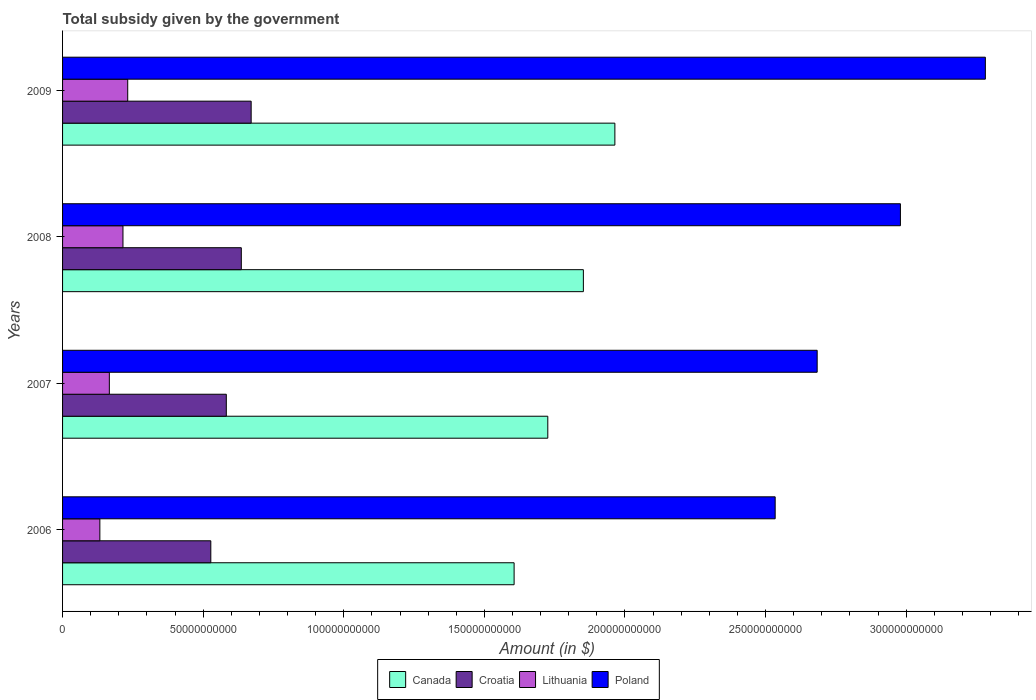How many different coloured bars are there?
Provide a short and direct response. 4. Are the number of bars per tick equal to the number of legend labels?
Provide a succinct answer. Yes. Are the number of bars on each tick of the Y-axis equal?
Offer a very short reply. Yes. How many bars are there on the 1st tick from the bottom?
Ensure brevity in your answer.  4. What is the total revenue collected by the government in Croatia in 2006?
Make the answer very short. 5.27e+1. Across all years, what is the maximum total revenue collected by the government in Lithuania?
Ensure brevity in your answer.  2.32e+1. Across all years, what is the minimum total revenue collected by the government in Poland?
Keep it short and to the point. 2.53e+11. What is the total total revenue collected by the government in Canada in the graph?
Your answer should be compact. 7.15e+11. What is the difference between the total revenue collected by the government in Poland in 2006 and that in 2007?
Make the answer very short. -1.49e+1. What is the difference between the total revenue collected by the government in Lithuania in 2006 and the total revenue collected by the government in Canada in 2008?
Offer a very short reply. -1.72e+11. What is the average total revenue collected by the government in Canada per year?
Ensure brevity in your answer.  1.79e+11. In the year 2008, what is the difference between the total revenue collected by the government in Canada and total revenue collected by the government in Croatia?
Make the answer very short. 1.22e+11. What is the ratio of the total revenue collected by the government in Lithuania in 2007 to that in 2009?
Your response must be concise. 0.72. Is the difference between the total revenue collected by the government in Canada in 2007 and 2008 greater than the difference between the total revenue collected by the government in Croatia in 2007 and 2008?
Your answer should be very brief. No. What is the difference between the highest and the second highest total revenue collected by the government in Croatia?
Offer a terse response. 3.51e+09. What is the difference between the highest and the lowest total revenue collected by the government in Croatia?
Give a very brief answer. 1.43e+1. Is the sum of the total revenue collected by the government in Lithuania in 2006 and 2007 greater than the maximum total revenue collected by the government in Croatia across all years?
Your answer should be compact. No. Is it the case that in every year, the sum of the total revenue collected by the government in Canada and total revenue collected by the government in Lithuania is greater than the sum of total revenue collected by the government in Croatia and total revenue collected by the government in Poland?
Ensure brevity in your answer.  Yes. What does the 3rd bar from the bottom in 2006 represents?
Make the answer very short. Lithuania. Is it the case that in every year, the sum of the total revenue collected by the government in Canada and total revenue collected by the government in Poland is greater than the total revenue collected by the government in Croatia?
Provide a short and direct response. Yes. Are all the bars in the graph horizontal?
Ensure brevity in your answer.  Yes. Are the values on the major ticks of X-axis written in scientific E-notation?
Your answer should be very brief. No. Where does the legend appear in the graph?
Your answer should be very brief. Bottom center. What is the title of the graph?
Your answer should be compact. Total subsidy given by the government. What is the label or title of the X-axis?
Give a very brief answer. Amount (in $). What is the label or title of the Y-axis?
Provide a short and direct response. Years. What is the Amount (in $) of Canada in 2006?
Make the answer very short. 1.61e+11. What is the Amount (in $) of Croatia in 2006?
Offer a very short reply. 5.27e+1. What is the Amount (in $) in Lithuania in 2006?
Provide a succinct answer. 1.33e+1. What is the Amount (in $) in Poland in 2006?
Offer a terse response. 2.53e+11. What is the Amount (in $) of Canada in 2007?
Ensure brevity in your answer.  1.73e+11. What is the Amount (in $) in Croatia in 2007?
Provide a short and direct response. 5.82e+1. What is the Amount (in $) of Lithuania in 2007?
Keep it short and to the point. 1.66e+1. What is the Amount (in $) of Poland in 2007?
Keep it short and to the point. 2.68e+11. What is the Amount (in $) in Canada in 2008?
Offer a terse response. 1.85e+11. What is the Amount (in $) of Croatia in 2008?
Make the answer very short. 6.36e+1. What is the Amount (in $) in Lithuania in 2008?
Keep it short and to the point. 2.15e+1. What is the Amount (in $) in Poland in 2008?
Provide a succinct answer. 2.98e+11. What is the Amount (in $) in Canada in 2009?
Give a very brief answer. 1.96e+11. What is the Amount (in $) in Croatia in 2009?
Your answer should be very brief. 6.71e+1. What is the Amount (in $) in Lithuania in 2009?
Provide a short and direct response. 2.32e+1. What is the Amount (in $) in Poland in 2009?
Make the answer very short. 3.28e+11. Across all years, what is the maximum Amount (in $) of Canada?
Your answer should be compact. 1.96e+11. Across all years, what is the maximum Amount (in $) of Croatia?
Your response must be concise. 6.71e+1. Across all years, what is the maximum Amount (in $) of Lithuania?
Provide a succinct answer. 2.32e+1. Across all years, what is the maximum Amount (in $) of Poland?
Ensure brevity in your answer.  3.28e+11. Across all years, what is the minimum Amount (in $) in Canada?
Provide a succinct answer. 1.61e+11. Across all years, what is the minimum Amount (in $) in Croatia?
Give a very brief answer. 5.27e+1. Across all years, what is the minimum Amount (in $) of Lithuania?
Your answer should be very brief. 1.33e+1. Across all years, what is the minimum Amount (in $) in Poland?
Your answer should be very brief. 2.53e+11. What is the total Amount (in $) of Canada in the graph?
Your answer should be very brief. 7.15e+11. What is the total Amount (in $) of Croatia in the graph?
Provide a short and direct response. 2.42e+11. What is the total Amount (in $) in Lithuania in the graph?
Your answer should be compact. 7.45e+1. What is the total Amount (in $) in Poland in the graph?
Keep it short and to the point. 1.15e+12. What is the difference between the Amount (in $) in Canada in 2006 and that in 2007?
Provide a succinct answer. -1.20e+1. What is the difference between the Amount (in $) of Croatia in 2006 and that in 2007?
Make the answer very short. -5.51e+09. What is the difference between the Amount (in $) of Lithuania in 2006 and that in 2007?
Ensure brevity in your answer.  -3.37e+09. What is the difference between the Amount (in $) of Poland in 2006 and that in 2007?
Give a very brief answer. -1.49e+1. What is the difference between the Amount (in $) of Canada in 2006 and that in 2008?
Keep it short and to the point. -2.46e+1. What is the difference between the Amount (in $) in Croatia in 2006 and that in 2008?
Make the answer very short. -1.08e+1. What is the difference between the Amount (in $) of Lithuania in 2006 and that in 2008?
Ensure brevity in your answer.  -8.22e+09. What is the difference between the Amount (in $) of Poland in 2006 and that in 2008?
Give a very brief answer. -4.45e+1. What is the difference between the Amount (in $) of Canada in 2006 and that in 2009?
Your response must be concise. -3.58e+1. What is the difference between the Amount (in $) in Croatia in 2006 and that in 2009?
Make the answer very short. -1.43e+1. What is the difference between the Amount (in $) of Lithuania in 2006 and that in 2009?
Make the answer very short. -9.90e+09. What is the difference between the Amount (in $) in Poland in 2006 and that in 2009?
Ensure brevity in your answer.  -7.47e+1. What is the difference between the Amount (in $) of Canada in 2007 and that in 2008?
Make the answer very short. -1.27e+1. What is the difference between the Amount (in $) of Croatia in 2007 and that in 2008?
Provide a succinct answer. -5.33e+09. What is the difference between the Amount (in $) of Lithuania in 2007 and that in 2008?
Make the answer very short. -4.85e+09. What is the difference between the Amount (in $) of Poland in 2007 and that in 2008?
Make the answer very short. -2.96e+1. What is the difference between the Amount (in $) of Canada in 2007 and that in 2009?
Your response must be concise. -2.39e+1. What is the difference between the Amount (in $) in Croatia in 2007 and that in 2009?
Ensure brevity in your answer.  -8.84e+09. What is the difference between the Amount (in $) of Lithuania in 2007 and that in 2009?
Your answer should be compact. -6.53e+09. What is the difference between the Amount (in $) in Poland in 2007 and that in 2009?
Your answer should be very brief. -5.98e+1. What is the difference between the Amount (in $) in Canada in 2008 and that in 2009?
Offer a terse response. -1.12e+1. What is the difference between the Amount (in $) in Croatia in 2008 and that in 2009?
Offer a very short reply. -3.51e+09. What is the difference between the Amount (in $) in Lithuania in 2008 and that in 2009?
Your answer should be very brief. -1.69e+09. What is the difference between the Amount (in $) of Poland in 2008 and that in 2009?
Keep it short and to the point. -3.02e+1. What is the difference between the Amount (in $) of Canada in 2006 and the Amount (in $) of Croatia in 2007?
Provide a succinct answer. 1.02e+11. What is the difference between the Amount (in $) in Canada in 2006 and the Amount (in $) in Lithuania in 2007?
Give a very brief answer. 1.44e+11. What is the difference between the Amount (in $) of Canada in 2006 and the Amount (in $) of Poland in 2007?
Offer a terse response. -1.08e+11. What is the difference between the Amount (in $) in Croatia in 2006 and the Amount (in $) in Lithuania in 2007?
Your answer should be very brief. 3.61e+1. What is the difference between the Amount (in $) of Croatia in 2006 and the Amount (in $) of Poland in 2007?
Your response must be concise. -2.16e+11. What is the difference between the Amount (in $) in Lithuania in 2006 and the Amount (in $) in Poland in 2007?
Your response must be concise. -2.55e+11. What is the difference between the Amount (in $) in Canada in 2006 and the Amount (in $) in Croatia in 2008?
Provide a short and direct response. 9.70e+1. What is the difference between the Amount (in $) of Canada in 2006 and the Amount (in $) of Lithuania in 2008?
Give a very brief answer. 1.39e+11. What is the difference between the Amount (in $) of Canada in 2006 and the Amount (in $) of Poland in 2008?
Offer a terse response. -1.37e+11. What is the difference between the Amount (in $) in Croatia in 2006 and the Amount (in $) in Lithuania in 2008?
Keep it short and to the point. 3.12e+1. What is the difference between the Amount (in $) of Croatia in 2006 and the Amount (in $) of Poland in 2008?
Your response must be concise. -2.45e+11. What is the difference between the Amount (in $) in Lithuania in 2006 and the Amount (in $) in Poland in 2008?
Offer a very short reply. -2.85e+11. What is the difference between the Amount (in $) of Canada in 2006 and the Amount (in $) of Croatia in 2009?
Make the answer very short. 9.35e+1. What is the difference between the Amount (in $) in Canada in 2006 and the Amount (in $) in Lithuania in 2009?
Your response must be concise. 1.37e+11. What is the difference between the Amount (in $) of Canada in 2006 and the Amount (in $) of Poland in 2009?
Keep it short and to the point. -1.68e+11. What is the difference between the Amount (in $) in Croatia in 2006 and the Amount (in $) in Lithuania in 2009?
Your answer should be very brief. 2.96e+1. What is the difference between the Amount (in $) in Croatia in 2006 and the Amount (in $) in Poland in 2009?
Make the answer very short. -2.75e+11. What is the difference between the Amount (in $) of Lithuania in 2006 and the Amount (in $) of Poland in 2009?
Provide a succinct answer. -3.15e+11. What is the difference between the Amount (in $) in Canada in 2007 and the Amount (in $) in Croatia in 2008?
Ensure brevity in your answer.  1.09e+11. What is the difference between the Amount (in $) of Canada in 2007 and the Amount (in $) of Lithuania in 2008?
Give a very brief answer. 1.51e+11. What is the difference between the Amount (in $) in Canada in 2007 and the Amount (in $) in Poland in 2008?
Offer a terse response. -1.25e+11. What is the difference between the Amount (in $) of Croatia in 2007 and the Amount (in $) of Lithuania in 2008?
Your answer should be compact. 3.67e+1. What is the difference between the Amount (in $) of Croatia in 2007 and the Amount (in $) of Poland in 2008?
Provide a succinct answer. -2.40e+11. What is the difference between the Amount (in $) in Lithuania in 2007 and the Amount (in $) in Poland in 2008?
Offer a terse response. -2.81e+11. What is the difference between the Amount (in $) of Canada in 2007 and the Amount (in $) of Croatia in 2009?
Offer a terse response. 1.05e+11. What is the difference between the Amount (in $) of Canada in 2007 and the Amount (in $) of Lithuania in 2009?
Your answer should be very brief. 1.49e+11. What is the difference between the Amount (in $) in Canada in 2007 and the Amount (in $) in Poland in 2009?
Provide a short and direct response. -1.56e+11. What is the difference between the Amount (in $) in Croatia in 2007 and the Amount (in $) in Lithuania in 2009?
Provide a short and direct response. 3.51e+1. What is the difference between the Amount (in $) of Croatia in 2007 and the Amount (in $) of Poland in 2009?
Your response must be concise. -2.70e+11. What is the difference between the Amount (in $) of Lithuania in 2007 and the Amount (in $) of Poland in 2009?
Offer a very short reply. -3.12e+11. What is the difference between the Amount (in $) of Canada in 2008 and the Amount (in $) of Croatia in 2009?
Provide a succinct answer. 1.18e+11. What is the difference between the Amount (in $) in Canada in 2008 and the Amount (in $) in Lithuania in 2009?
Your answer should be compact. 1.62e+11. What is the difference between the Amount (in $) in Canada in 2008 and the Amount (in $) in Poland in 2009?
Give a very brief answer. -1.43e+11. What is the difference between the Amount (in $) of Croatia in 2008 and the Amount (in $) of Lithuania in 2009?
Your response must be concise. 4.04e+1. What is the difference between the Amount (in $) in Croatia in 2008 and the Amount (in $) in Poland in 2009?
Ensure brevity in your answer.  -2.65e+11. What is the difference between the Amount (in $) of Lithuania in 2008 and the Amount (in $) of Poland in 2009?
Keep it short and to the point. -3.07e+11. What is the average Amount (in $) in Canada per year?
Your answer should be very brief. 1.79e+11. What is the average Amount (in $) in Croatia per year?
Make the answer very short. 6.04e+1. What is the average Amount (in $) in Lithuania per year?
Provide a succinct answer. 1.86e+1. What is the average Amount (in $) in Poland per year?
Offer a very short reply. 2.87e+11. In the year 2006, what is the difference between the Amount (in $) of Canada and Amount (in $) of Croatia?
Keep it short and to the point. 1.08e+11. In the year 2006, what is the difference between the Amount (in $) in Canada and Amount (in $) in Lithuania?
Provide a succinct answer. 1.47e+11. In the year 2006, what is the difference between the Amount (in $) in Canada and Amount (in $) in Poland?
Give a very brief answer. -9.28e+1. In the year 2006, what is the difference between the Amount (in $) of Croatia and Amount (in $) of Lithuania?
Your answer should be compact. 3.95e+1. In the year 2006, what is the difference between the Amount (in $) of Croatia and Amount (in $) of Poland?
Provide a succinct answer. -2.01e+11. In the year 2006, what is the difference between the Amount (in $) of Lithuania and Amount (in $) of Poland?
Your answer should be very brief. -2.40e+11. In the year 2007, what is the difference between the Amount (in $) of Canada and Amount (in $) of Croatia?
Make the answer very short. 1.14e+11. In the year 2007, what is the difference between the Amount (in $) in Canada and Amount (in $) in Lithuania?
Your response must be concise. 1.56e+11. In the year 2007, what is the difference between the Amount (in $) in Canada and Amount (in $) in Poland?
Offer a terse response. -9.58e+1. In the year 2007, what is the difference between the Amount (in $) of Croatia and Amount (in $) of Lithuania?
Give a very brief answer. 4.16e+1. In the year 2007, what is the difference between the Amount (in $) of Croatia and Amount (in $) of Poland?
Your response must be concise. -2.10e+11. In the year 2007, what is the difference between the Amount (in $) of Lithuania and Amount (in $) of Poland?
Your response must be concise. -2.52e+11. In the year 2008, what is the difference between the Amount (in $) in Canada and Amount (in $) in Croatia?
Keep it short and to the point. 1.22e+11. In the year 2008, what is the difference between the Amount (in $) of Canada and Amount (in $) of Lithuania?
Offer a terse response. 1.64e+11. In the year 2008, what is the difference between the Amount (in $) of Canada and Amount (in $) of Poland?
Offer a terse response. -1.13e+11. In the year 2008, what is the difference between the Amount (in $) in Croatia and Amount (in $) in Lithuania?
Offer a terse response. 4.21e+1. In the year 2008, what is the difference between the Amount (in $) in Croatia and Amount (in $) in Poland?
Your answer should be very brief. -2.34e+11. In the year 2008, what is the difference between the Amount (in $) of Lithuania and Amount (in $) of Poland?
Your answer should be compact. -2.76e+11. In the year 2009, what is the difference between the Amount (in $) in Canada and Amount (in $) in Croatia?
Offer a terse response. 1.29e+11. In the year 2009, what is the difference between the Amount (in $) of Canada and Amount (in $) of Lithuania?
Give a very brief answer. 1.73e+11. In the year 2009, what is the difference between the Amount (in $) in Canada and Amount (in $) in Poland?
Give a very brief answer. -1.32e+11. In the year 2009, what is the difference between the Amount (in $) in Croatia and Amount (in $) in Lithuania?
Offer a very short reply. 4.39e+1. In the year 2009, what is the difference between the Amount (in $) in Croatia and Amount (in $) in Poland?
Provide a succinct answer. -2.61e+11. In the year 2009, what is the difference between the Amount (in $) in Lithuania and Amount (in $) in Poland?
Make the answer very short. -3.05e+11. What is the ratio of the Amount (in $) in Canada in 2006 to that in 2007?
Your answer should be compact. 0.93. What is the ratio of the Amount (in $) in Croatia in 2006 to that in 2007?
Your response must be concise. 0.91. What is the ratio of the Amount (in $) in Lithuania in 2006 to that in 2007?
Offer a terse response. 0.8. What is the ratio of the Amount (in $) in Poland in 2006 to that in 2007?
Make the answer very short. 0.94. What is the ratio of the Amount (in $) in Canada in 2006 to that in 2008?
Offer a very short reply. 0.87. What is the ratio of the Amount (in $) in Croatia in 2006 to that in 2008?
Provide a succinct answer. 0.83. What is the ratio of the Amount (in $) of Lithuania in 2006 to that in 2008?
Your response must be concise. 0.62. What is the ratio of the Amount (in $) in Poland in 2006 to that in 2008?
Give a very brief answer. 0.85. What is the ratio of the Amount (in $) of Canada in 2006 to that in 2009?
Give a very brief answer. 0.82. What is the ratio of the Amount (in $) of Croatia in 2006 to that in 2009?
Ensure brevity in your answer.  0.79. What is the ratio of the Amount (in $) in Lithuania in 2006 to that in 2009?
Your answer should be compact. 0.57. What is the ratio of the Amount (in $) of Poland in 2006 to that in 2009?
Your response must be concise. 0.77. What is the ratio of the Amount (in $) of Canada in 2007 to that in 2008?
Keep it short and to the point. 0.93. What is the ratio of the Amount (in $) in Croatia in 2007 to that in 2008?
Ensure brevity in your answer.  0.92. What is the ratio of the Amount (in $) of Lithuania in 2007 to that in 2008?
Provide a short and direct response. 0.77. What is the ratio of the Amount (in $) of Poland in 2007 to that in 2008?
Offer a terse response. 0.9. What is the ratio of the Amount (in $) in Canada in 2007 to that in 2009?
Your answer should be very brief. 0.88. What is the ratio of the Amount (in $) in Croatia in 2007 to that in 2009?
Provide a succinct answer. 0.87. What is the ratio of the Amount (in $) in Lithuania in 2007 to that in 2009?
Provide a short and direct response. 0.72. What is the ratio of the Amount (in $) in Poland in 2007 to that in 2009?
Provide a short and direct response. 0.82. What is the ratio of the Amount (in $) in Canada in 2008 to that in 2009?
Give a very brief answer. 0.94. What is the ratio of the Amount (in $) in Croatia in 2008 to that in 2009?
Your response must be concise. 0.95. What is the ratio of the Amount (in $) of Lithuania in 2008 to that in 2009?
Provide a short and direct response. 0.93. What is the ratio of the Amount (in $) of Poland in 2008 to that in 2009?
Ensure brevity in your answer.  0.91. What is the difference between the highest and the second highest Amount (in $) of Canada?
Your answer should be compact. 1.12e+1. What is the difference between the highest and the second highest Amount (in $) in Croatia?
Your answer should be compact. 3.51e+09. What is the difference between the highest and the second highest Amount (in $) in Lithuania?
Offer a terse response. 1.69e+09. What is the difference between the highest and the second highest Amount (in $) of Poland?
Provide a succinct answer. 3.02e+1. What is the difference between the highest and the lowest Amount (in $) of Canada?
Give a very brief answer. 3.58e+1. What is the difference between the highest and the lowest Amount (in $) of Croatia?
Your answer should be very brief. 1.43e+1. What is the difference between the highest and the lowest Amount (in $) in Lithuania?
Make the answer very short. 9.90e+09. What is the difference between the highest and the lowest Amount (in $) of Poland?
Your answer should be compact. 7.47e+1. 